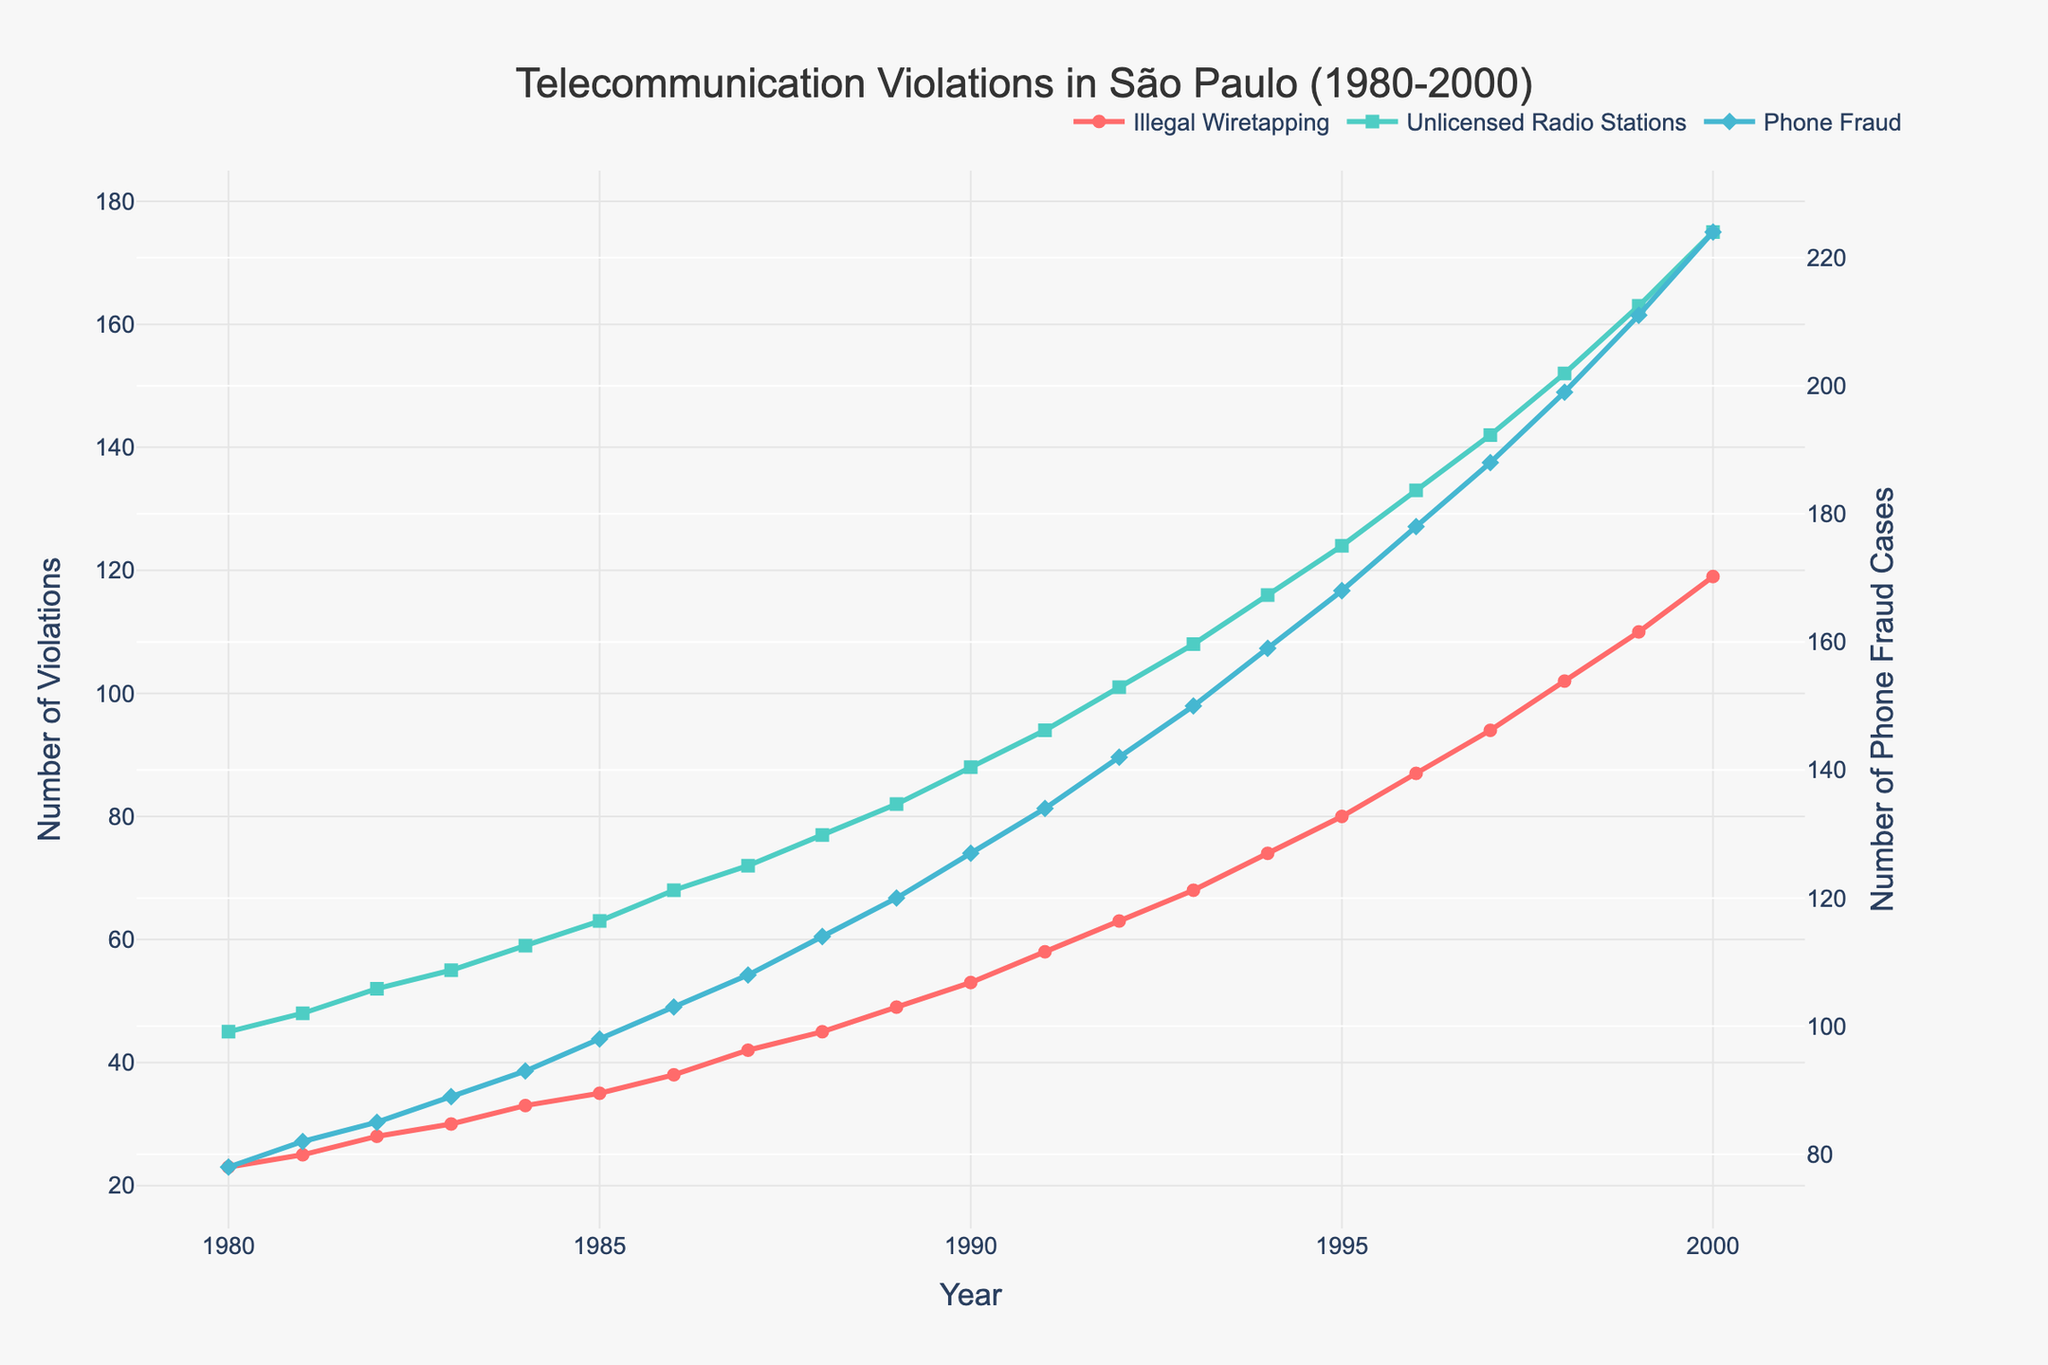What year does Illegal Wiretapping first surpass 40 cases? In the figure, follow the "Illegal Wiretapping" line until it crosses the marker showing 40 cases. This threshold is first crossed between 1986 and 1987. Specifically, in 1987, the number reaches 42.
Answer: 1987 Which type of telecommunication violation had the highest count in 2000? Examine the endpoints for each type of violation in 2000. Illegal Wiretapping, Unlicensed Radio Stations, and Phone Fraud are represented by different lines. Phone Fraud has the highest count in 2000, reaching 224.
Answer: Phone Fraud By how much did the number of Unlicensed Radio Stations increase from 1980 to 2000? Read the values for Unlicensed Radio Stations for 1980 and 2000 from the line chart. In 1980, there are 45 cases, and in 2000, 175 cases. The increase is obtained by subtracting the 1980 value from the 2000 value (175 - 45 = 130).
Answer: 130 What is the average annual increase in Phone Fraud cases between 1990 and 2000? First, find the number of Phone Fraud cases in 1990 (127) and 2000 (224). Over ten years, the increase is 224 - 127 = 97 cases. Divide this by 10 to get the average annual increase.
Answer: 9.7 In which year was the difference between Unlicensed Radio Stations and Phone Fraud the smallest? Calculate the difference between the counts of Unlicensed Radio Stations and Phone Fraud for each year. Identify the year where this difference is the smallest. From the figure, it is clear the smallest difference is in 1980, where Phone Fraud (78) and Unlicensed Radio Stations (45) differ by 33 cases.
Answer: 1980 Which violation type consistently increases every year without any decline? Inspect each line representing the different violations and look for any dips or declines. Illegal Wiretapping shows a consistent increase without any reduction.
Answer: Illegal Wiretapping What was the trend in the number of Illegal Wiretapping cases between 1985 and 1995? Locate the points marking Illegal Wiretapping cases in 1985 and 1995. There is a steady upward trend from 35 cases in 1985 to 80 cases in 1995.
Answer: Increasing By what percentage did Phone Fraud grow from 1980 to 2000? Identify the counts for Phone Fraud in 1980 (78 cases) and 2000 (224 cases). Calculate the percentage growth using the formula ((224 - 78) / 78) * 100.
Answer: 187.18% Which year shows a noticeable spike in Unlicensed Radio Stations cases relative to its surrounding years? Observe spikes in the plotted line for Unlicensed Radio Stations. A noticeable spike occurs around 1998 compared to surrounding years (an increase from 142 to 152).
Answer: 1998 